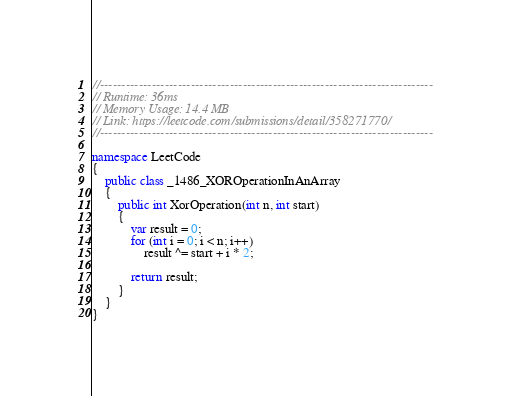<code> <loc_0><loc_0><loc_500><loc_500><_C#_>//-----------------------------------------------------------------------------
// Runtime: 36ms
// Memory Usage: 14.4 MB
// Link: https://leetcode.com/submissions/detail/358271770/
//-----------------------------------------------------------------------------

namespace LeetCode
{
    public class _1486_XOROperationInAnArray
    {
        public int XorOperation(int n, int start)
        {
            var result = 0;
            for (int i = 0; i < n; i++)
                result ^= start + i * 2;

            return result;
        }
    }
}
</code> 